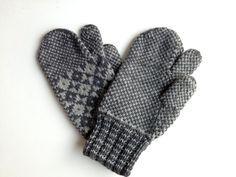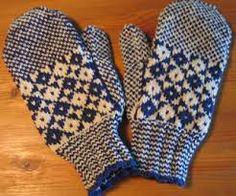The first image is the image on the left, the second image is the image on the right. Given the left and right images, does the statement "There are gloves with heart pattern shown." hold true? Answer yes or no. No. The first image is the image on the left, the second image is the image on the right. Examine the images to the left and right. Is the description "The mittens in one of the images are lying on a wooden surface" accurate? Answer yes or no. Yes. 